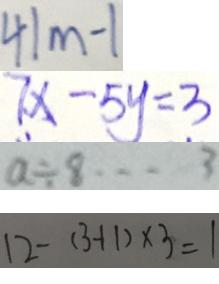Convert formula to latex. <formula><loc_0><loc_0><loc_500><loc_500>4 1 m - 1 
 7 x - 5 y = 3 
 a \div 8 \cdots 3 
 1 2 - ( 3 - 1 1 ) \times 3 = 1</formula> 